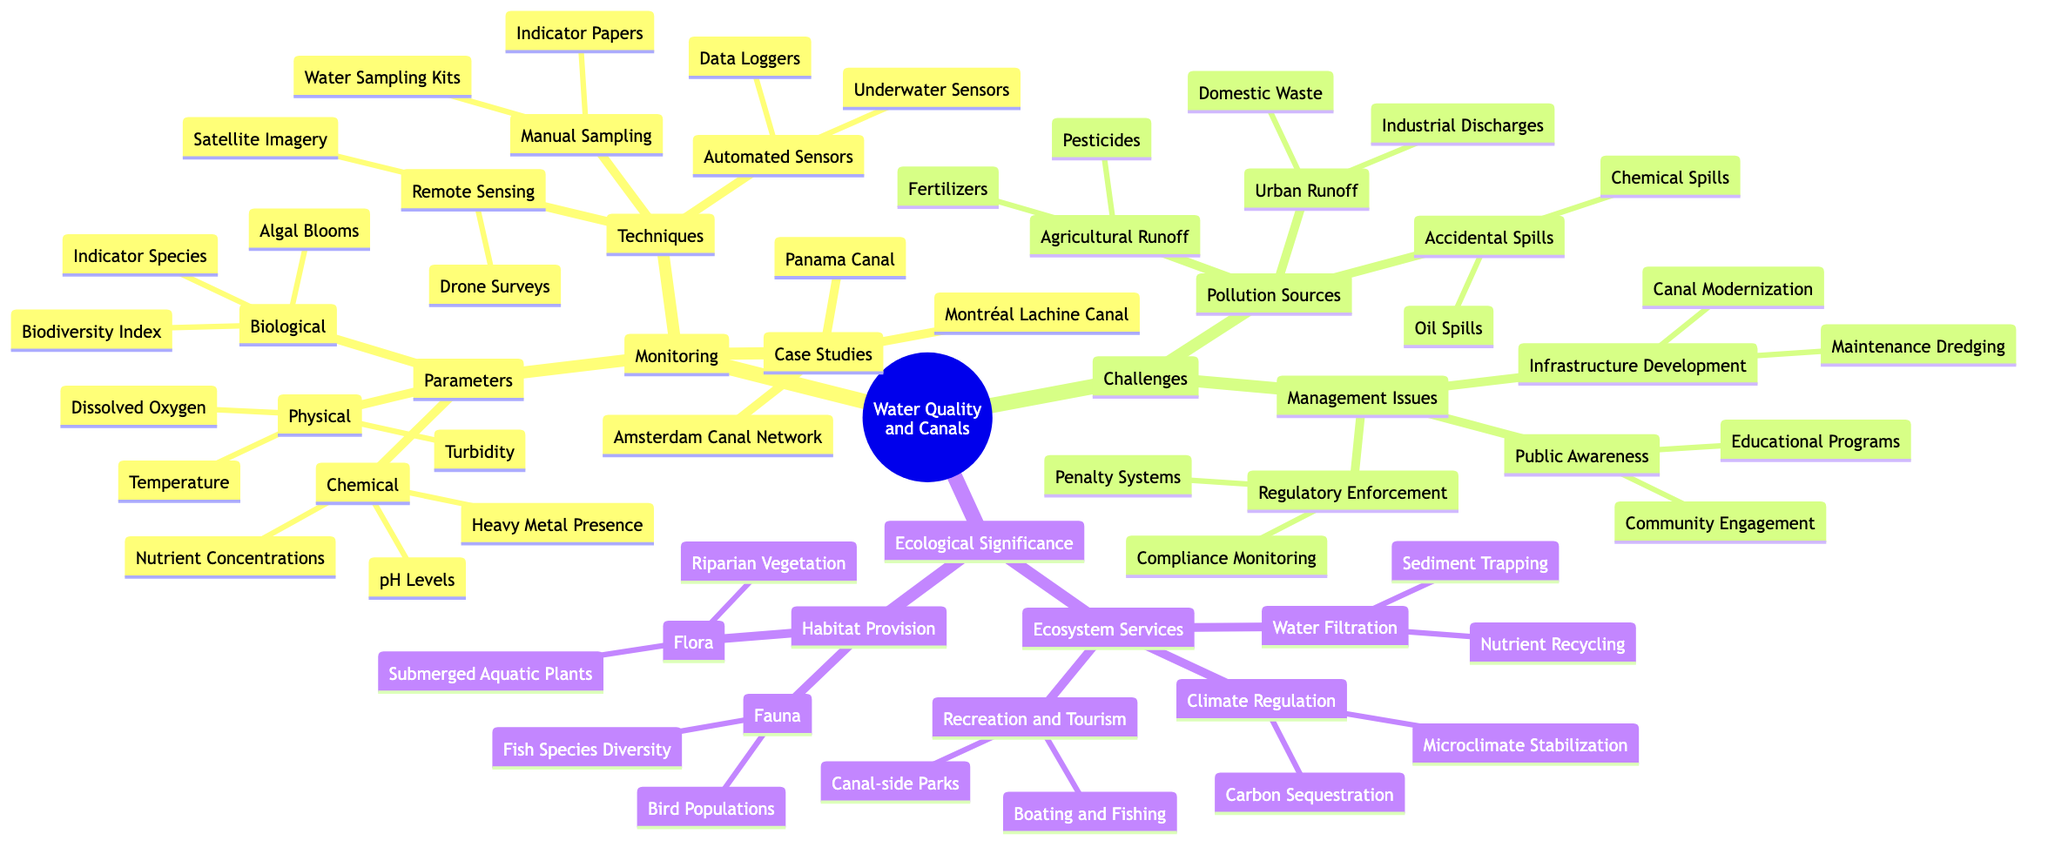What are the three categories of monitoring parameters? The diagram specifies "Chemical", "Biological", and "Physical" as the three main categories under the "Monitoring" node.
Answer: Chemical, Biological, Physical How many techniques are there under monitoring? There are three main techniques listed: "Manual Sampling", "Remote Sensing", and "Automated Sensors". Thus, the count is three.
Answer: 3 What are the two types of pollution sources? The two types of pollution sources in the diagram are "Agricultural Runoff" and "Urban Runoff". The context of pollution sources under "Challenges" emphasizes these categories.
Answer: Agricultural Runoff, Urban Runoff Which types of ecosystem services are mentioned? The types of ecosystem services listed are "Water Filtration", "Climate Regulation", and "Recreation and Tourism". This indicates a diverse set of services provided by the canal ecosystems.
Answer: Water Filtration, Climate Regulation, Recreation and Tourism Name one case study highlighted for water quality in canals. The diagram cites "Montréal Lachine Canal" as one of the case studies. This indicates a specific location that has been studied for its water quality implications.
Answer: Montréal Lachine Canal What is a method used in manual sampling? The diagram lists "Water Sampling Kits" as one of the methods used under the "Manual Sampling" technique, indicating a practical tool for monitoring water quality.
Answer: Water Sampling Kits How many types of fauna are identified in habitat provision? Under "Habitat Provision", the diagram identifies two types of fauna: "Fish Species Diversity" and "Bird Populations", leading to a total of two.
Answer: 2 What are two challenges related to management issues? The "Challenges" section lists "Regulatory Enforcement" and "Infrastructure Development" as two of the management issues, both crucial for maintaining water quality and ecosystem health.
Answer: Regulatory Enforcement, Infrastructure Development What kind of species is indicated as a monitoring parameter? The diagram mentions "Indicator Species" under "Biological" monitoring parameters, highlighting its importance in assessing ecosystem health.
Answer: Indicator Species 